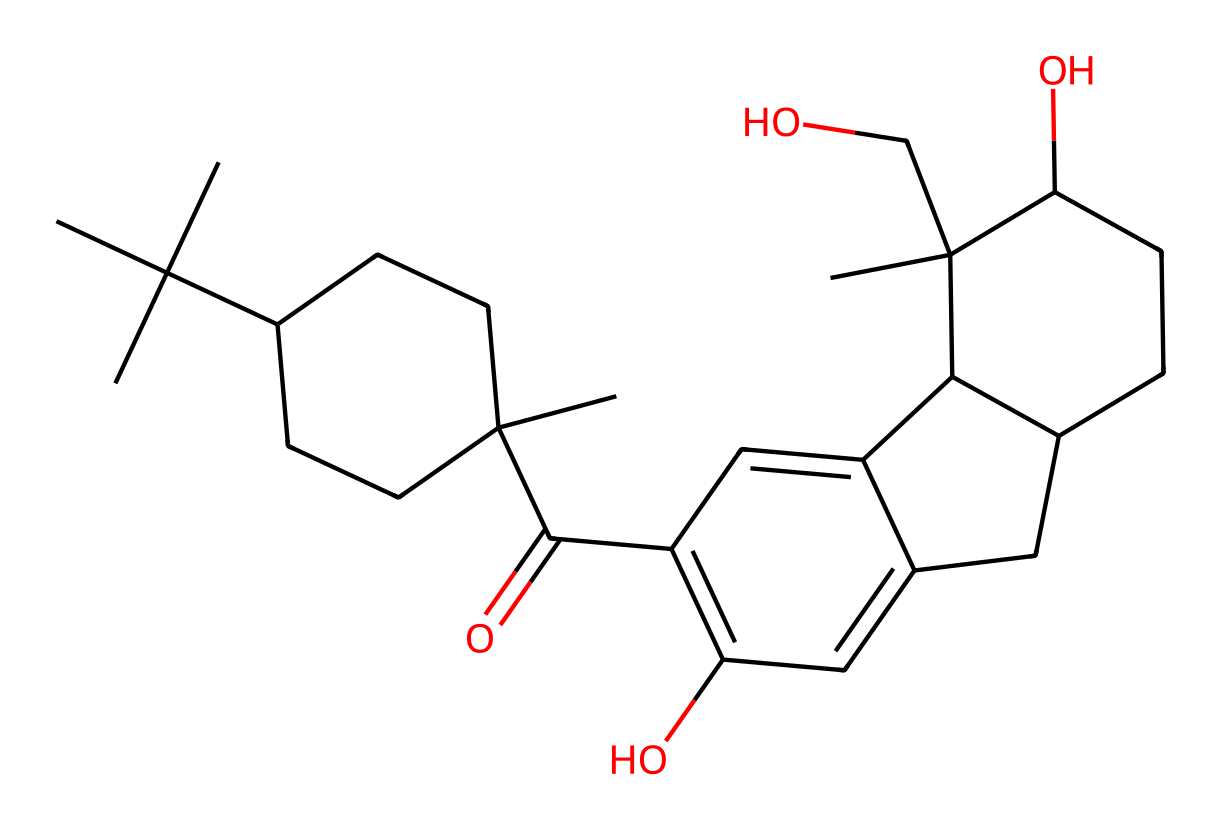What is the molecular formula of THC? To find the molecular formula, count the number of each type of atom in the chemical structure. In THC, there are 21 carbon (C) atoms, 30 hydrogen (H) atoms, and 2 oxygen (O) atoms. Therefore, the molecular formula is C21H30O2.
Answer: C21H30O2 How many rings are present in the structure of THC? By examining the structure, THC contains a total of 3 rings formed by the cyclic structures of carbons in its backbone. Each ring is formed by carbons bonded in a closed loop.
Answer: 3 What type of compound is THC classified as? THC is classified as a cannabinoid, which is a type of chemical compound that interacts with cannabinoid receptors in the body. This classification is based on its specific structure and its effect on the endocannabinoid system.
Answer: cannabinoid What functional groups are present in THC? The functional groups in THC include alcohol (–OH) groups and a ketone (C=O). These groups can be identified by their specific structures. The presence of these groups contributes to THC's reactivity and biological activity.
Answer: alcohol, ketone How many stereocenters are in THC? A stereocenter is a carbon atom that is bonded to four different groups. In THC's structure, there are 3 stereocenters, which means it can exist in multiple stereoisomeric forms.
Answer: 3 What is the significance of the hydroxyl groups in THC? Hydroxyl groups (–OH) increase the solubility of THC in water and influence its interaction with biological systems. Their presence plays a crucial role in the pharmacological properties of THC, particularly in how it affects the endocannabinoid system.
Answer: solubility, interaction What is the main biological effect of THC? The main biological effect of THC is psychoactivity, which means it alters perception, mood, and cognition when it binds to cannabinoid receptors in the brain. This effect is central to its use in recreational and medicinal contexts.
Answer: psychoactivity 